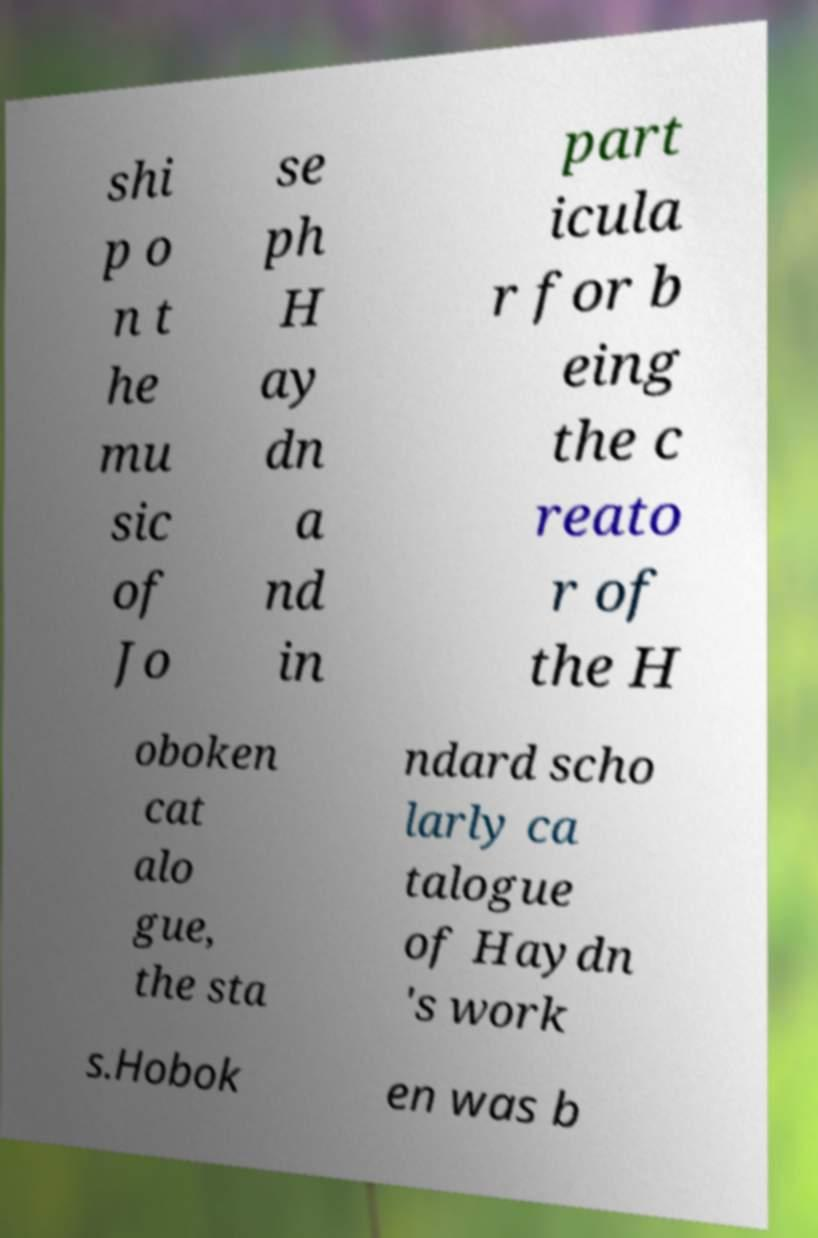Please read and relay the text visible in this image. What does it say? shi p o n t he mu sic of Jo se ph H ay dn a nd in part icula r for b eing the c reato r of the H oboken cat alo gue, the sta ndard scho larly ca talogue of Haydn 's work s.Hobok en was b 